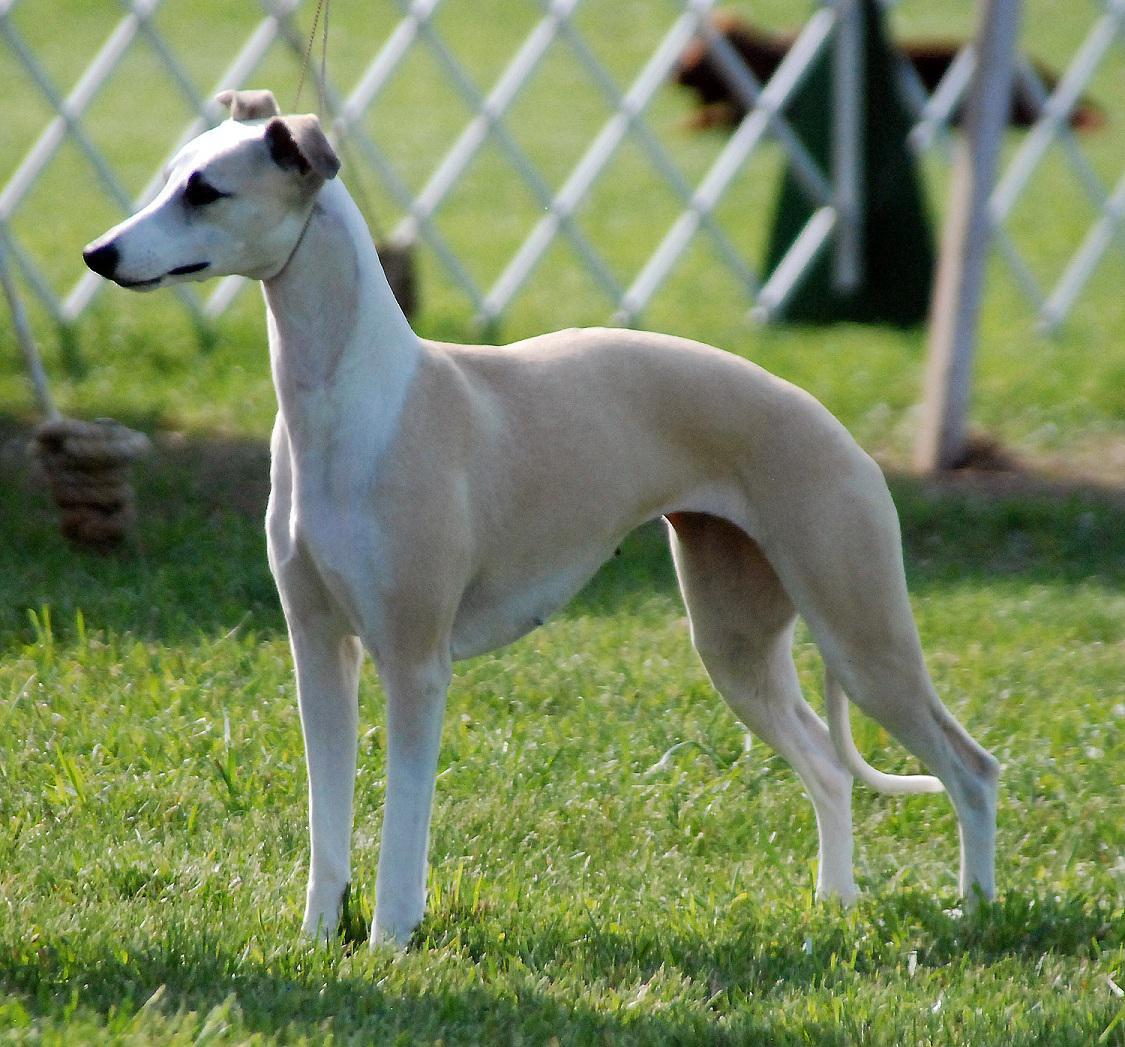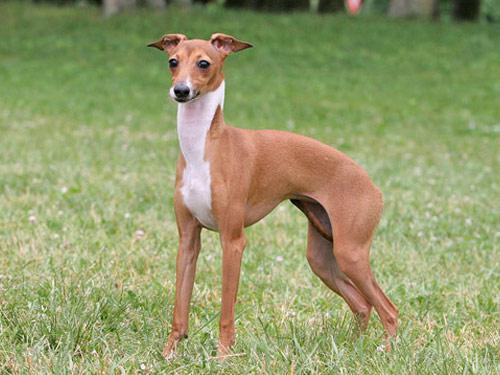The first image is the image on the left, the second image is the image on the right. Evaluate the accuracy of this statement regarding the images: "At least one image shows a tan dog with a white chest standing on grass, facing leftward.". Is it true? Answer yes or no. Yes. The first image is the image on the left, the second image is the image on the right. Examine the images to the left and right. Is the description "The right image contains at least two dogs." accurate? Answer yes or no. No. 